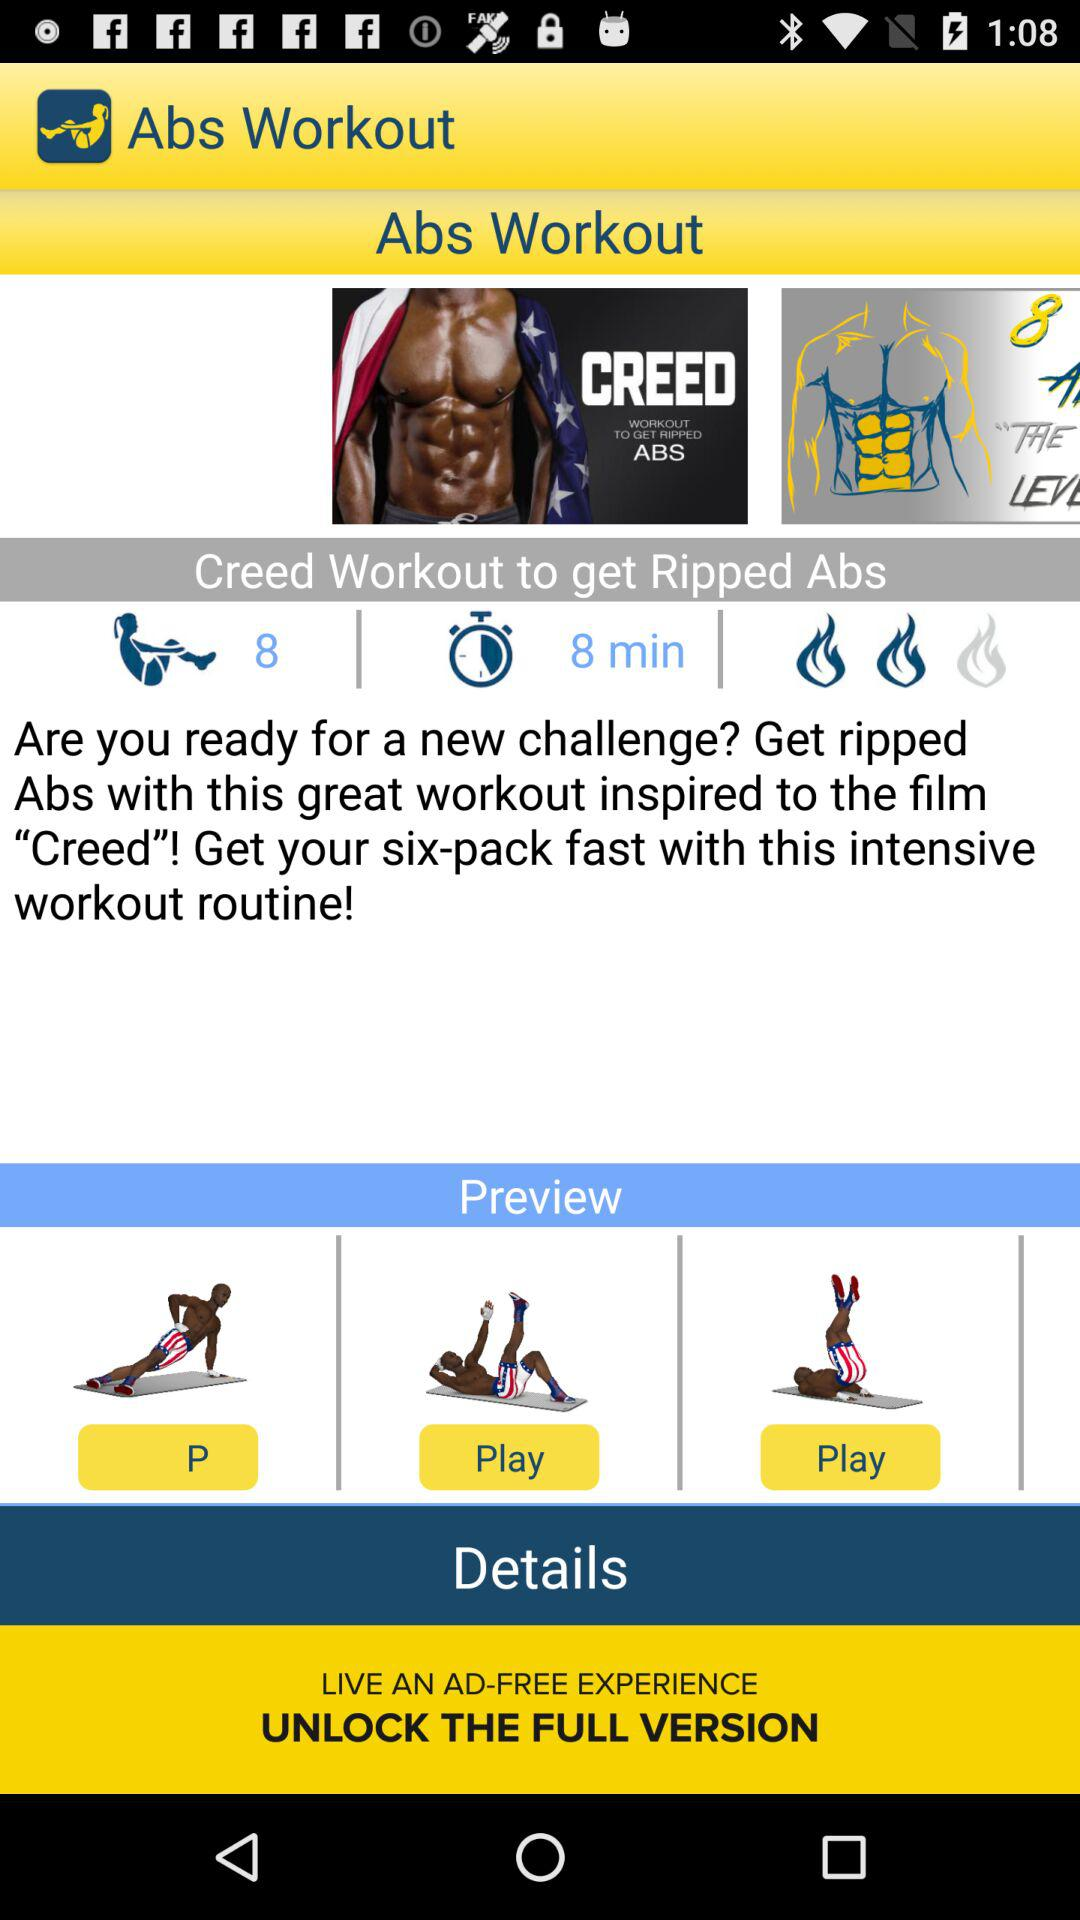What's the intensive rating of the exercise out of 3? The intensity rating of the exercise is 2 out of 3. 